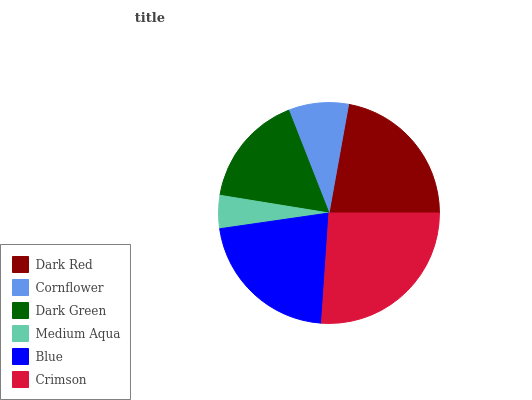Is Medium Aqua the minimum?
Answer yes or no. Yes. Is Crimson the maximum?
Answer yes or no. Yes. Is Cornflower the minimum?
Answer yes or no. No. Is Cornflower the maximum?
Answer yes or no. No. Is Dark Red greater than Cornflower?
Answer yes or no. Yes. Is Cornflower less than Dark Red?
Answer yes or no. Yes. Is Cornflower greater than Dark Red?
Answer yes or no. No. Is Dark Red less than Cornflower?
Answer yes or no. No. Is Blue the high median?
Answer yes or no. Yes. Is Dark Green the low median?
Answer yes or no. Yes. Is Medium Aqua the high median?
Answer yes or no. No. Is Dark Red the low median?
Answer yes or no. No. 